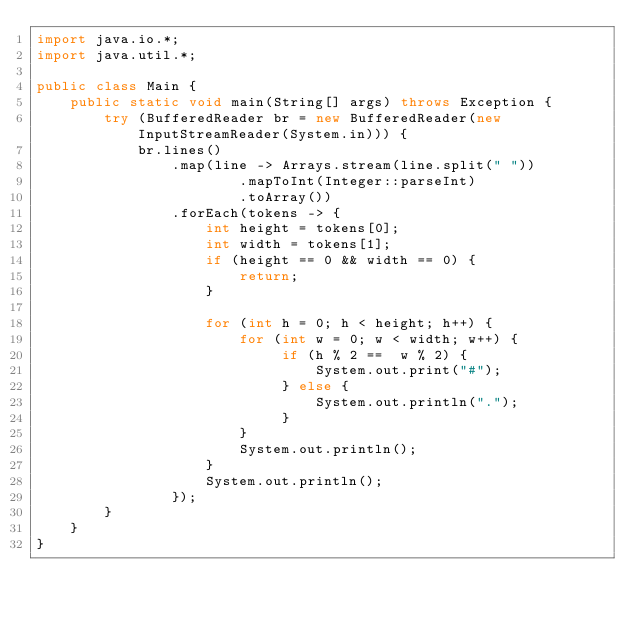<code> <loc_0><loc_0><loc_500><loc_500><_Java_>import java.io.*;
import java.util.*;
 
public class Main {
    public static void main(String[] args) throws Exception {
        try (BufferedReader br = new BufferedReader(new InputStreamReader(System.in))) {
            br.lines()
                .map(line -> Arrays.stream(line.split(" "))
                        .mapToInt(Integer::parseInt)
                        .toArray())
                .forEach(tokens -> {
                    int height = tokens[0];
                    int width = tokens[1];
                    if (height == 0 && width == 0) {
                        return;
                    }
 
                    for (int h = 0; h < height; h++) {
                        for (int w = 0; w < width; w++) {
                             if (h % 2 ==  w % 2) {
                                 System.out.print("#");
                             } else {
                                 System.out.println(".");
                             }
                        }
                        System.out.println();
                    }
                    System.out.println();
                });
        }
    }
}</code> 